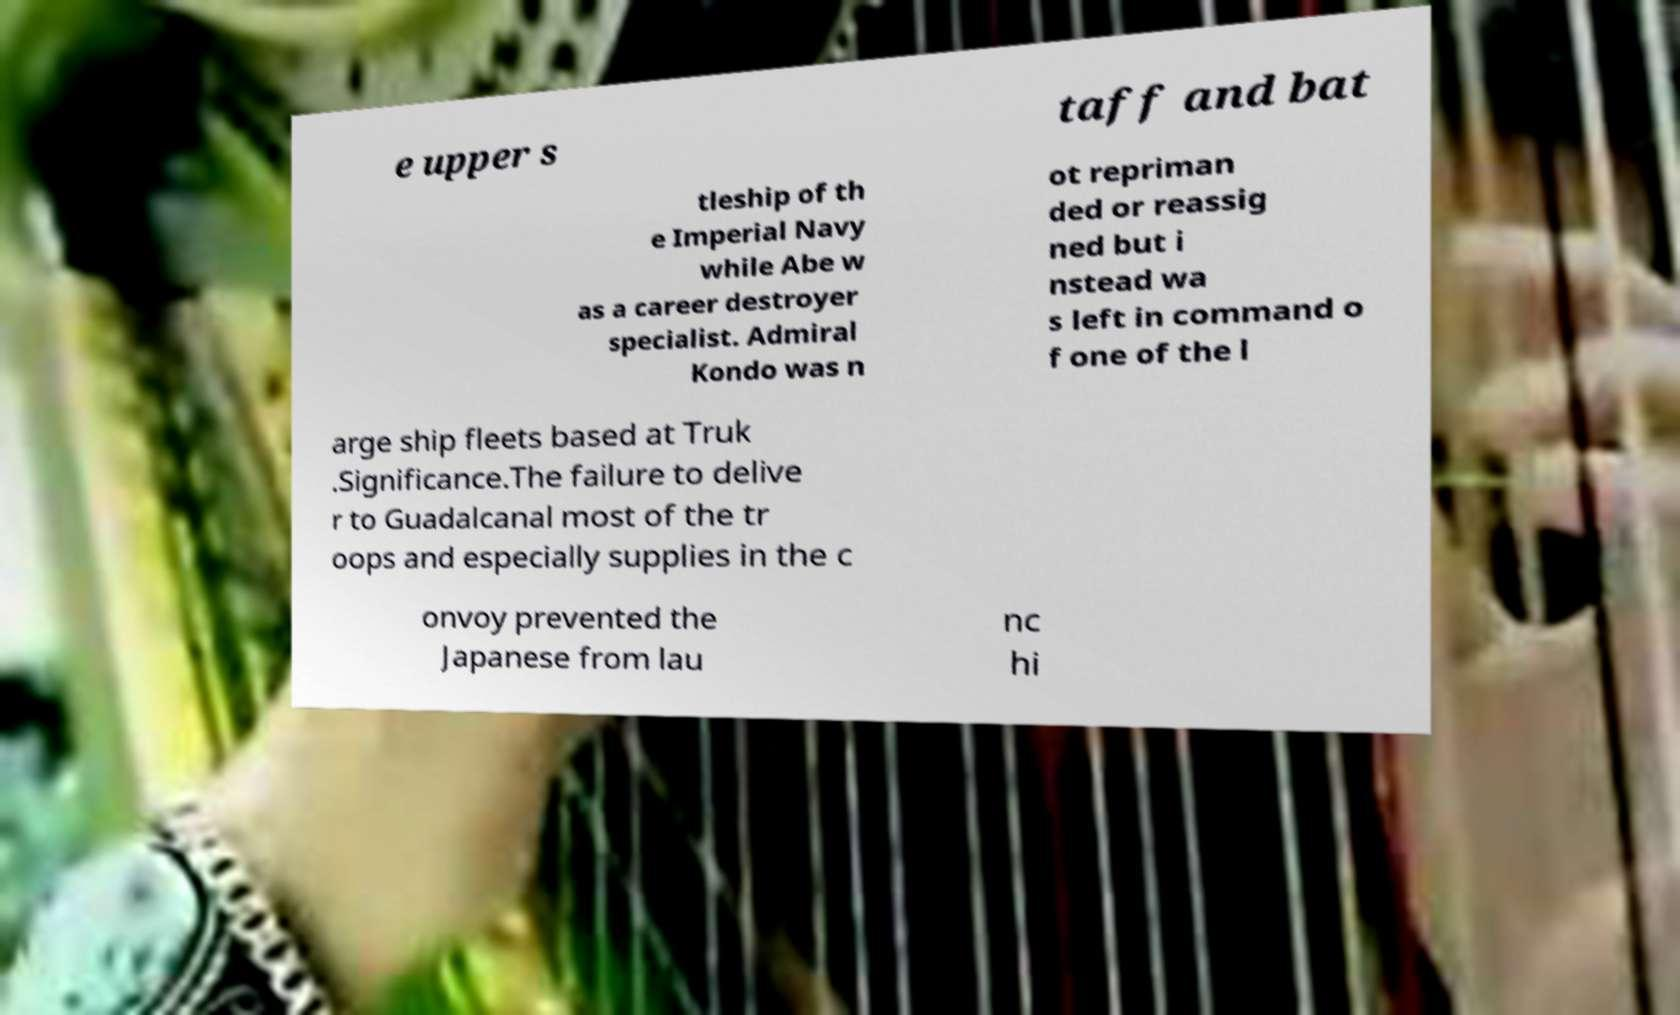Can you read and provide the text displayed in the image?This photo seems to have some interesting text. Can you extract and type it out for me? e upper s taff and bat tleship of th e Imperial Navy while Abe w as a career destroyer specialist. Admiral Kondo was n ot repriman ded or reassig ned but i nstead wa s left in command o f one of the l arge ship fleets based at Truk .Significance.The failure to delive r to Guadalcanal most of the tr oops and especially supplies in the c onvoy prevented the Japanese from lau nc hi 